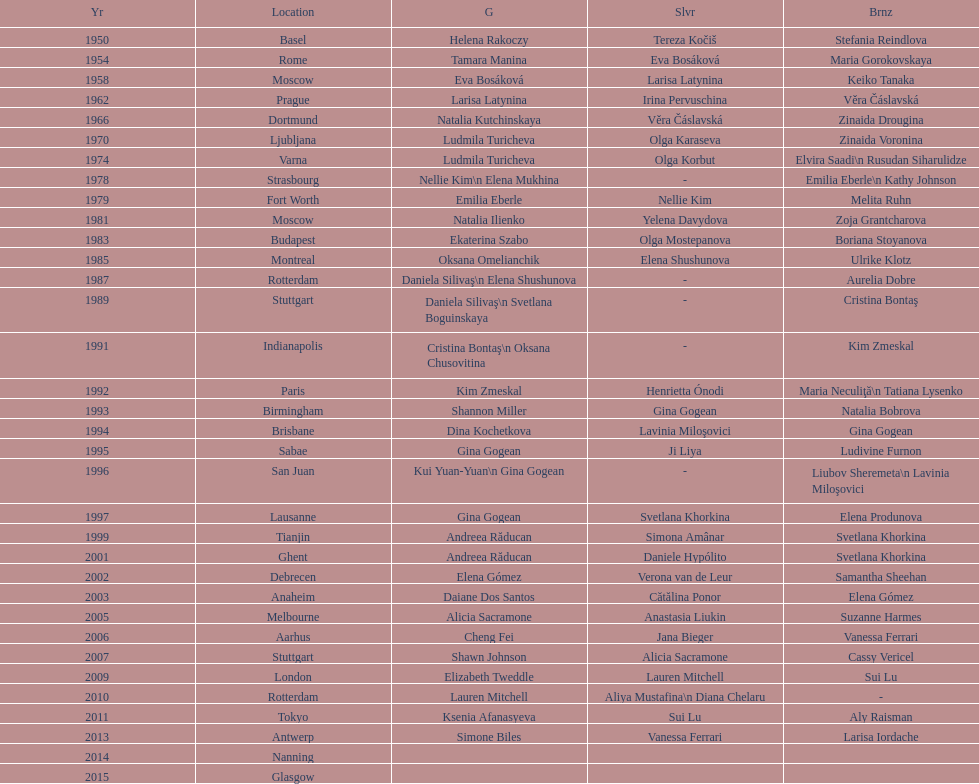As of 2013, what is the total number of floor exercise gold medals won by american women at the world championships? 5. 